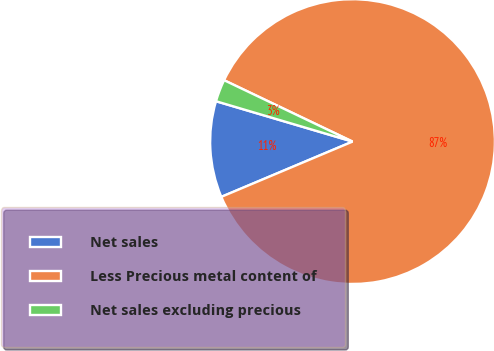Convert chart. <chart><loc_0><loc_0><loc_500><loc_500><pie_chart><fcel>Net sales<fcel>Less Precious metal content of<fcel>Net sales excluding precious<nl><fcel>10.92%<fcel>86.56%<fcel>2.52%<nl></chart> 